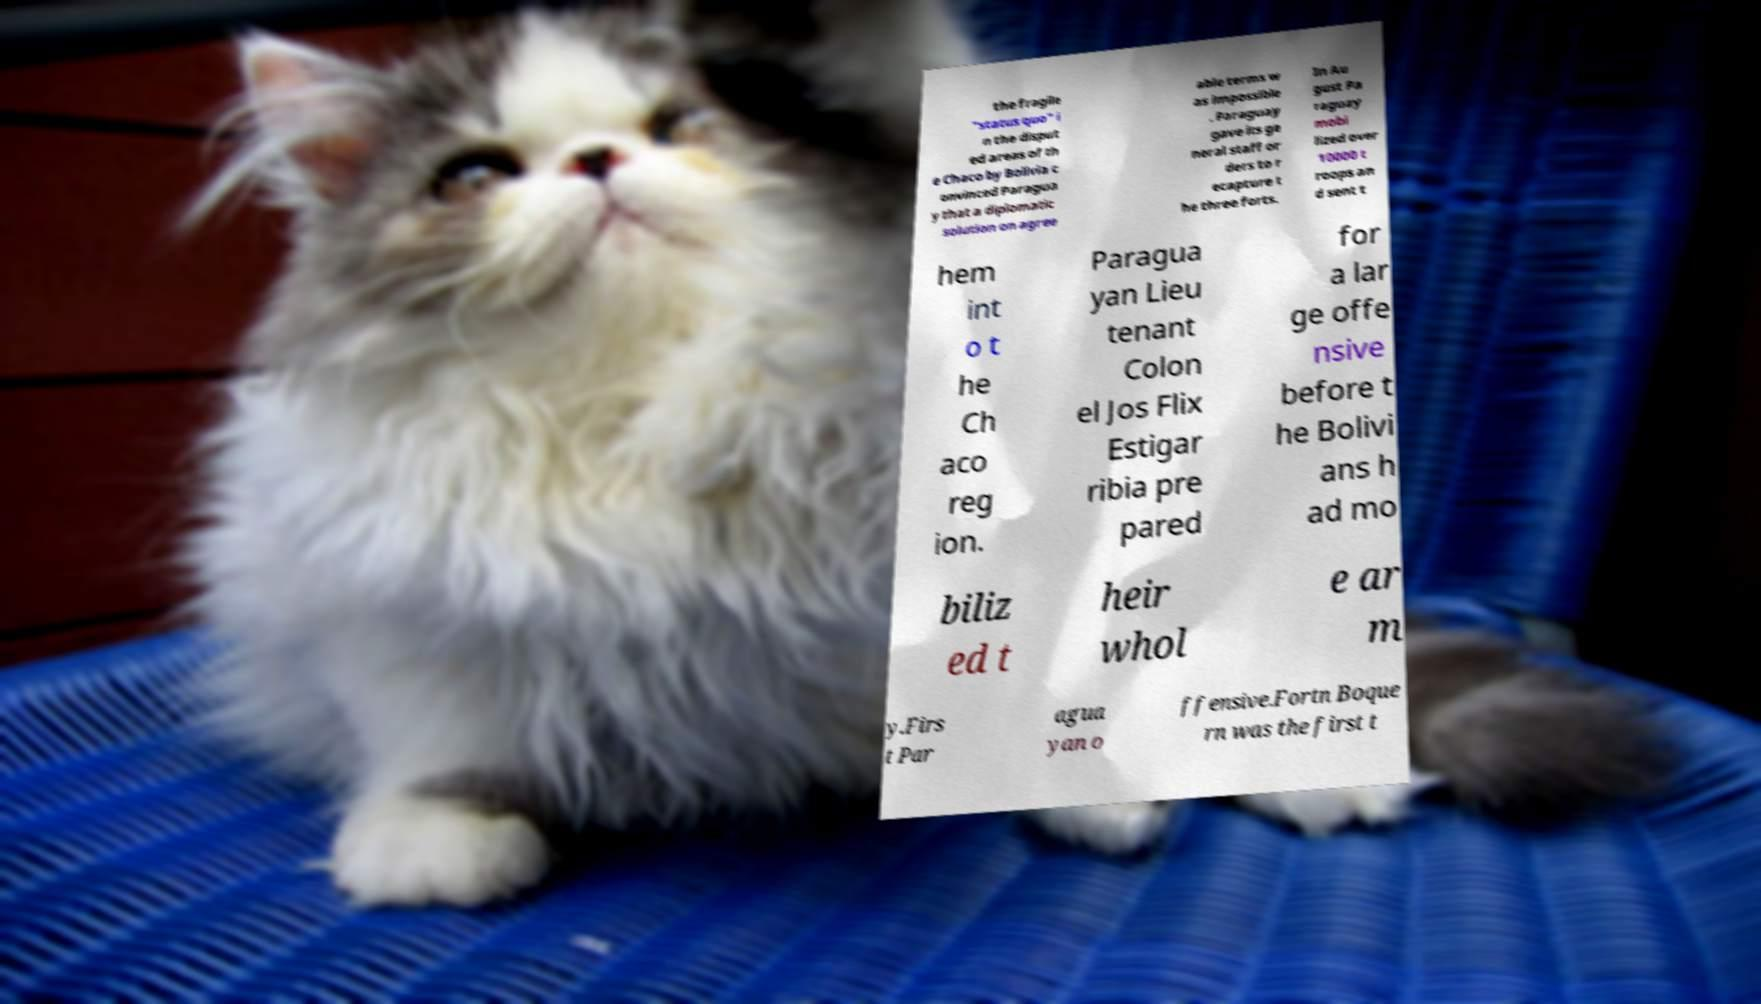I need the written content from this picture converted into text. Can you do that? the fragile "status quo" i n the disput ed areas of th e Chaco by Bolivia c onvinced Paragua y that a diplomatic solution on agree able terms w as impossible . Paraguay gave its ge neral staff or ders to r ecapture t he three forts. In Au gust Pa raguay mobi lized over 10000 t roops an d sent t hem int o t he Ch aco reg ion. Paragua yan Lieu tenant Colon el Jos Flix Estigar ribia pre pared for a lar ge offe nsive before t he Bolivi ans h ad mo biliz ed t heir whol e ar m y.Firs t Par agua yan o ffensive.Fortn Boque rn was the first t 